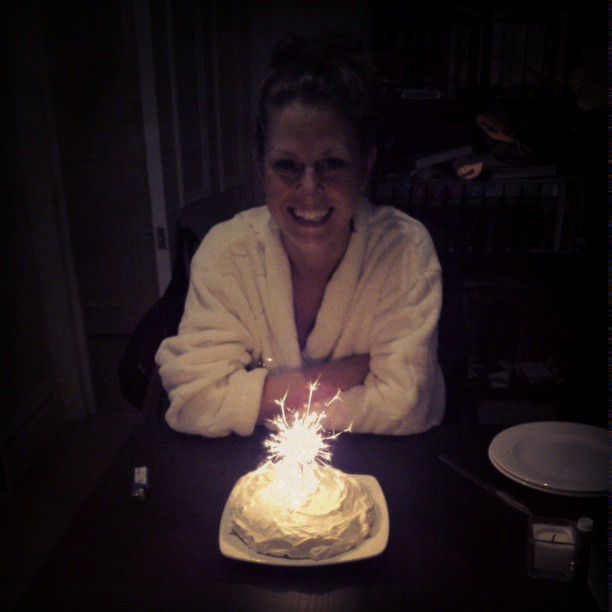What can be inferred about the setting of this birthday celebration? The setting is indoors, likely in a home, given the presence of books in the background and a more personal, casual setting. This setting helps create a relaxed and intimate birthday experience. 